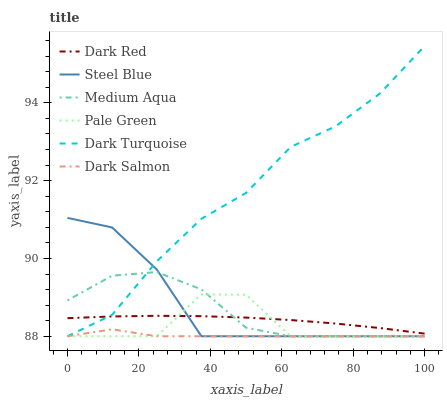Does Dark Salmon have the minimum area under the curve?
Answer yes or no. Yes. Does Dark Turquoise have the maximum area under the curve?
Answer yes or no. Yes. Does Steel Blue have the minimum area under the curve?
Answer yes or no. No. Does Steel Blue have the maximum area under the curve?
Answer yes or no. No. Is Dark Red the smoothest?
Answer yes or no. Yes. Is Pale Green the roughest?
Answer yes or no. Yes. Is Dark Salmon the smoothest?
Answer yes or no. No. Is Dark Salmon the roughest?
Answer yes or no. No. Does Dark Turquoise have the highest value?
Answer yes or no. Yes. Does Steel Blue have the highest value?
Answer yes or no. No. Is Dark Salmon less than Dark Red?
Answer yes or no. Yes. Is Dark Red greater than Dark Salmon?
Answer yes or no. Yes. Does Dark Salmon intersect Dark Red?
Answer yes or no. No. 